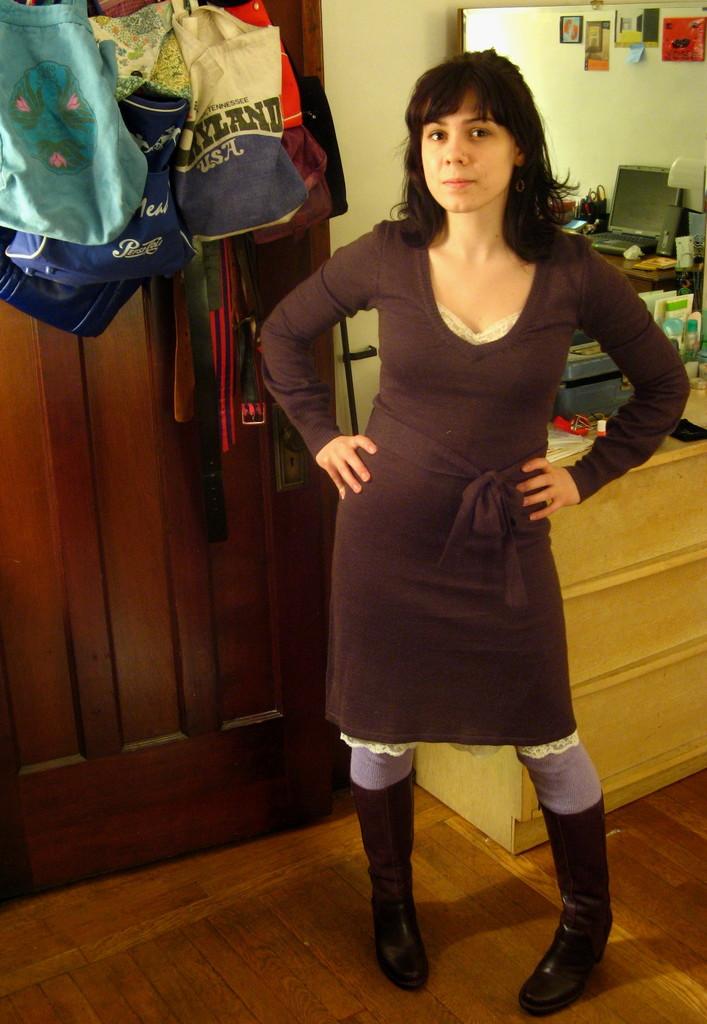What country was the bag made in?
Ensure brevity in your answer.  Usa. 